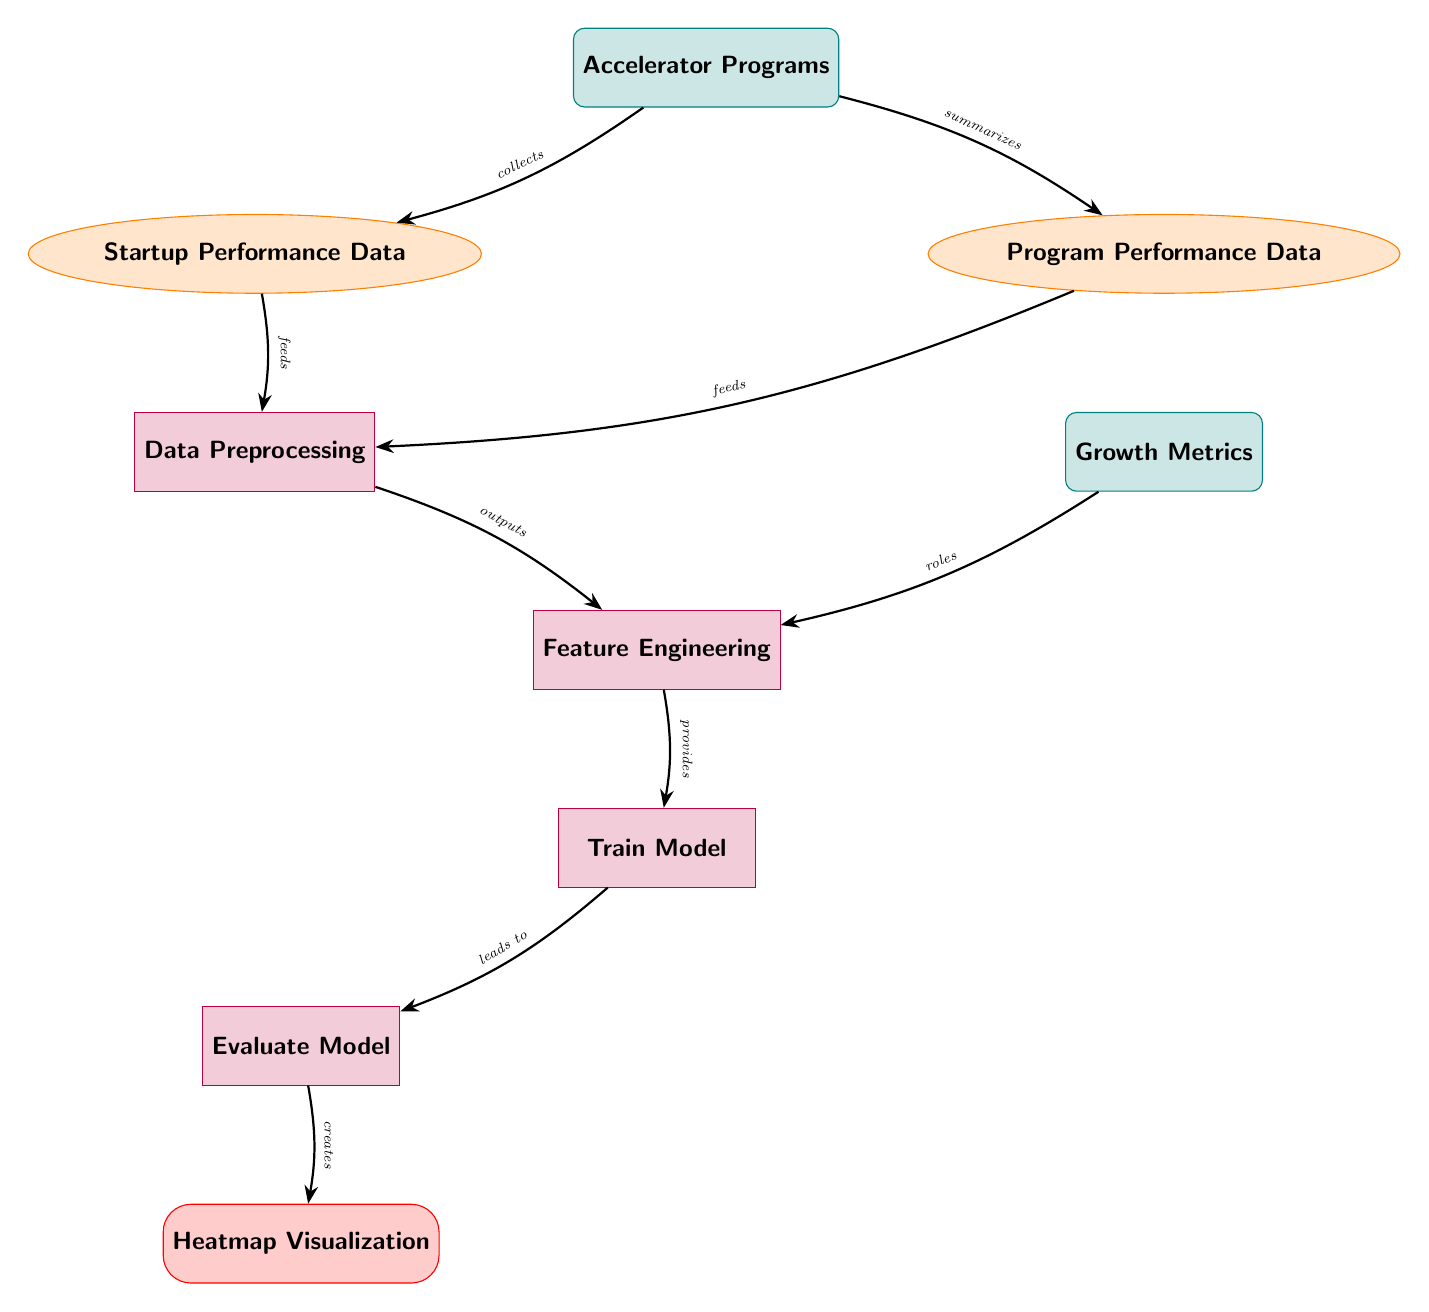What are the two types of data represented in the diagram? The diagram includes two types of data nodes: "Startup Performance Data" and "Program Performance Data". These are distinctly labeled in the diagram.
Answer: Startup Performance Data, Program Performance Data How many entities are in the diagram? Analyzing the diagram, we can identify four entities: "Accelerator Programs", "Growth Metrics", and two types of data, "Startup Performance Data" and "Program Performance Data", which are included as part of the relationships.
Answer: 4 Which process leads to the heatmap visualization? The process that leads to "Heatmap Visualization" is "Evaluate Model", which is directly before it in the flow of the diagram.
Answer: Evaluate Model What role do growth metrics play in the feature engineering process? The "Growth Metrics" node flows into the "Feature Engineering" process, indicating that they are a crucial part of shaping the features for the model training. This indicates their role in influencing the feature engineering step of the workflow.
Answer: Roles How many arrows connect "Accelerator Programs" to other nodes? Counting the arrows originating from "Accelerator Programs", we find that there are two arrows connecting it to "Startup Performance Data" and "Program Performance Data".
Answer: 2 What type of node is "Data Preprocessing"? "Data Preprocessing" is classified as a process node in the diagram. It is distinctly labeled with a process style design.
Answer: Process Which node directly feeds into the training model? The "Feature Engineering" node provides input to the "Train Model", establishing a direct relationship in the workflow.
Answer: Feature Engineering What is the output of the model evaluation process? The output of the "Evaluate Model" process is the "Heatmap Visualization", indicated by the subsequent arrow leading from the evaluation process to the output node.
Answer: Heatmap Visualization Which two nodes are necessary inputs for data preprocessing? The necessary inputs for data preprocessing are both "Startup Performance Data" and "Program Performance Data", as indicated by the arrows leading into the data processing node.
Answer: Startup Performance Data, Program Performance Data 